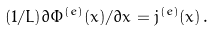<formula> <loc_0><loc_0><loc_500><loc_500>( 1 / L ) \partial \Phi ^ { ( e ) } ( x ) / \partial x = j ^ { ( e ) } ( x ) \, .</formula> 